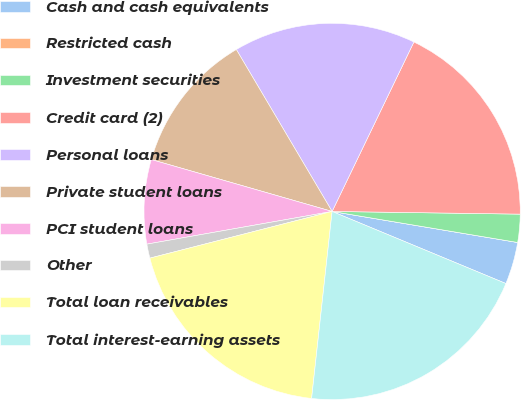Convert chart. <chart><loc_0><loc_0><loc_500><loc_500><pie_chart><fcel>Cash and cash equivalents<fcel>Restricted cash<fcel>Investment securities<fcel>Credit card (2)<fcel>Personal loans<fcel>Private student loans<fcel>PCI student loans<fcel>Other<fcel>Total loan receivables<fcel>Total interest-earning assets<nl><fcel>3.62%<fcel>0.0%<fcel>2.41%<fcel>18.07%<fcel>15.66%<fcel>12.05%<fcel>7.23%<fcel>1.21%<fcel>19.27%<fcel>20.48%<nl></chart> 